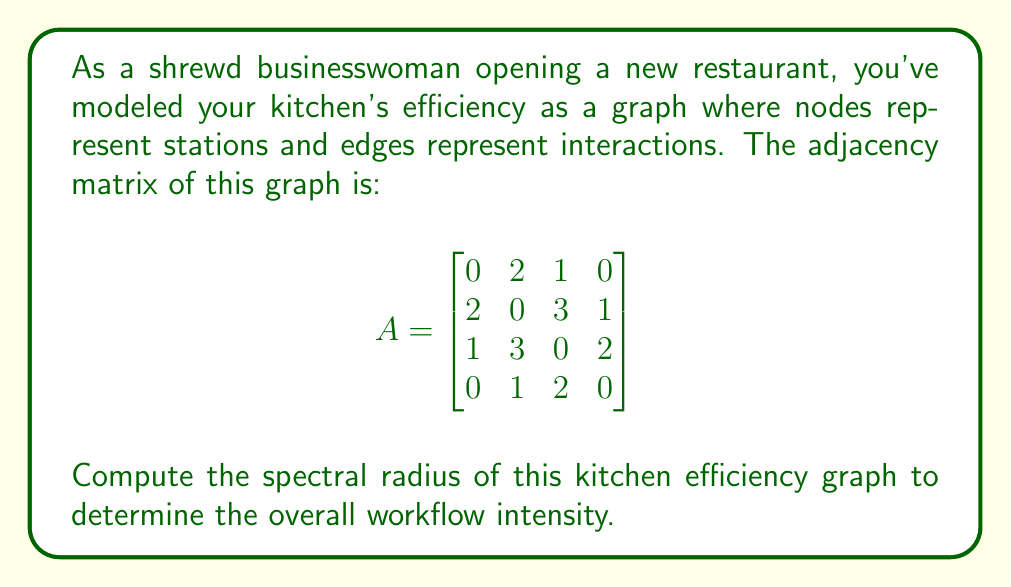Could you help me with this problem? To compute the spectral radius of the kitchen efficiency graph, we need to follow these steps:

1) The spectral radius is the largest absolute value of the eigenvalues of the adjacency matrix A.

2) To find the eigenvalues, we need to solve the characteristic equation:
   $$det(A - \lambda I) = 0$$

3) Expanding this determinant:
   $$\begin{vmatrix}
   -\lambda & 2 & 1 & 0 \\
   2 & -\lambda & 3 & 1 \\
   1 & 3 & -\lambda & 2 \\
   0 & 1 & 2 & -\lambda
   \end{vmatrix} = 0$$

4) This expands to the characteristic polynomial:
   $$\lambda^4 - 14\lambda^2 - 8\lambda + 9 = 0$$

5) This fourth-degree polynomial doesn't have a simple factorization. We need to use numerical methods to find its roots.

6) Using a computer algebra system or numerical solver, we find the roots (eigenvalues) are approximately:
   $$\lambda_1 \approx 4.2305$$
   $$\lambda_2 \approx -3.0414$$
   $$\lambda_3 \approx 1.4055$$
   $$\lambda_4 \approx -0.5946$$

7) The spectral radius is the largest absolute value among these eigenvalues, which is $|\lambda_1| \approx 4.2305$.
Answer: $4.2305$ 